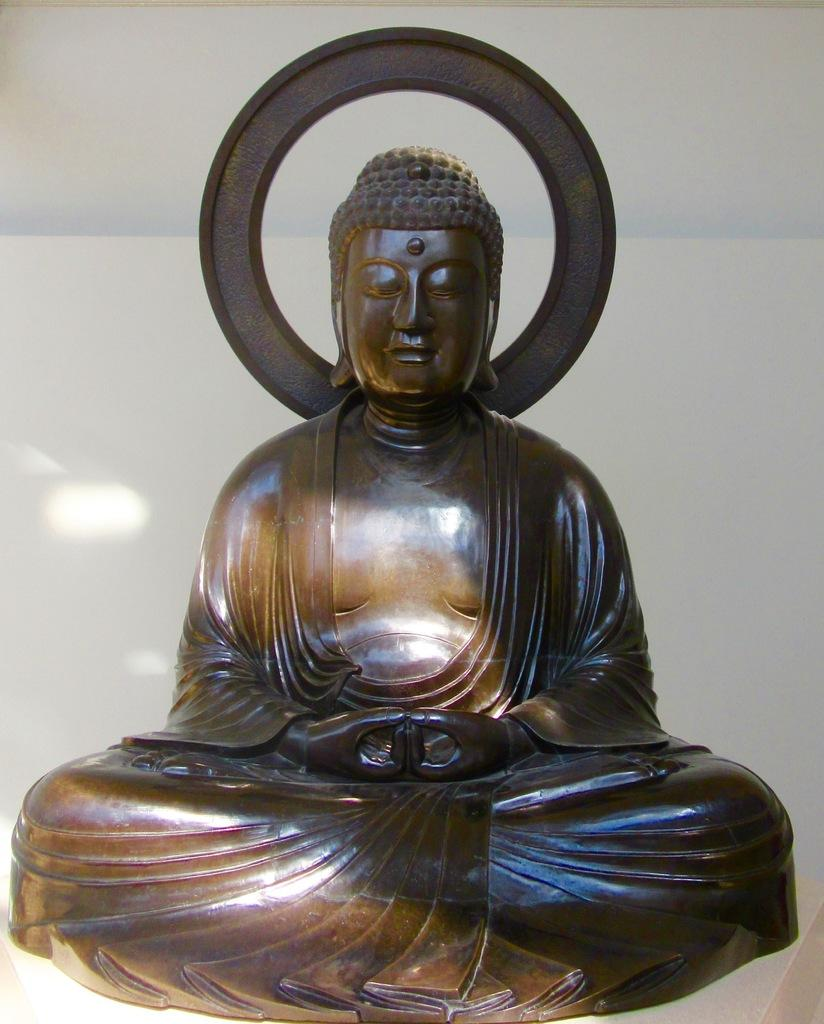What is the main subject of the image? There is a statue of Lord Buddha in the image. Can you describe the background of the image? The background of the image is visible. Is there any rain visible in the image? There is no rain visible in the image. What type of cream is being used to decorate the statue in the image? There is no cream present in the image; it features a statue of Lord Buddha with no visible decorations. 